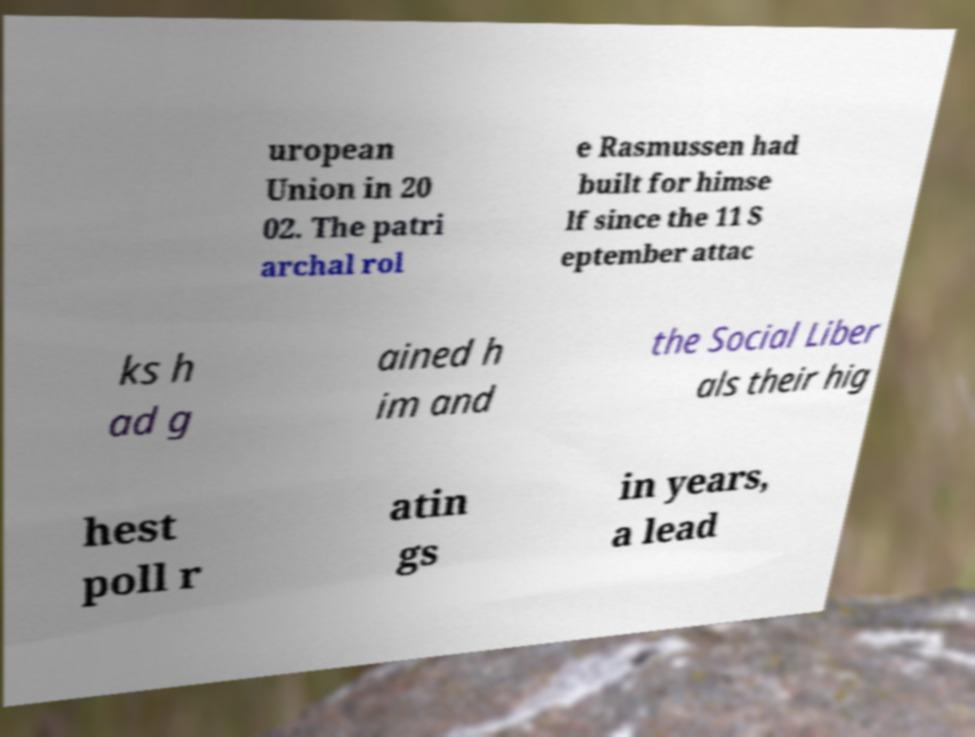There's text embedded in this image that I need extracted. Can you transcribe it verbatim? uropean Union in 20 02. The patri archal rol e Rasmussen had built for himse lf since the 11 S eptember attac ks h ad g ained h im and the Social Liber als their hig hest poll r atin gs in years, a lead 